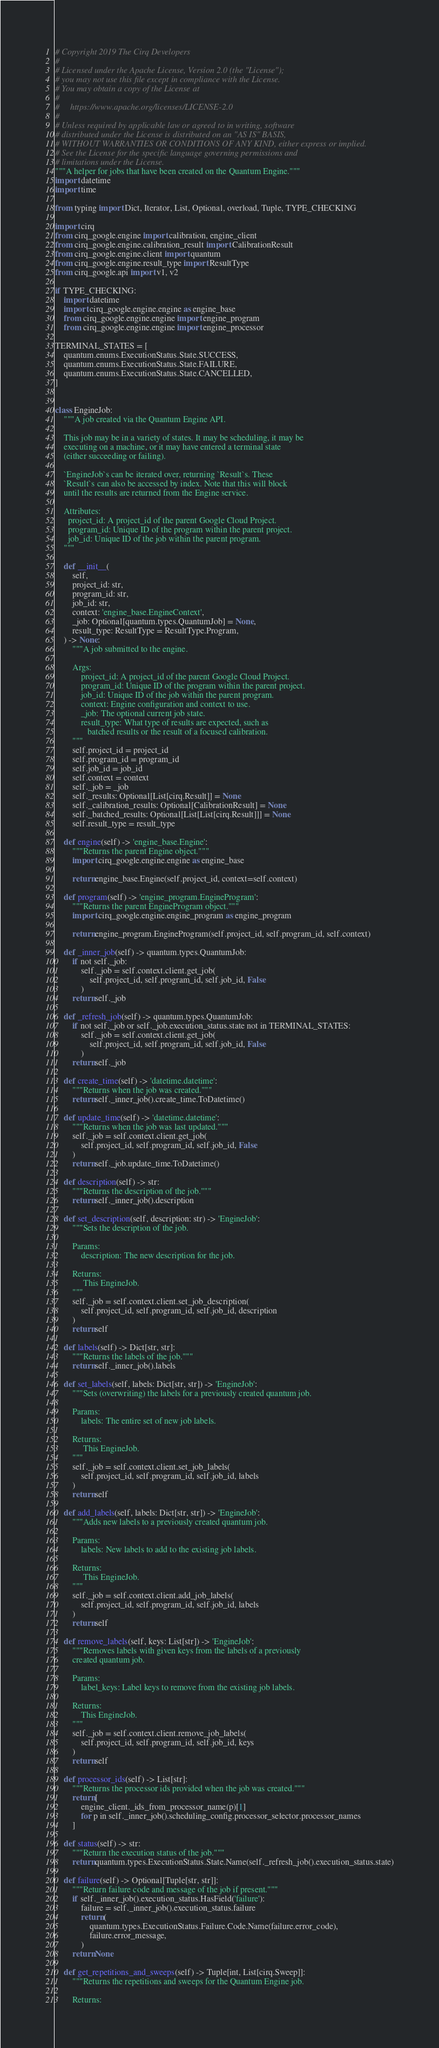<code> <loc_0><loc_0><loc_500><loc_500><_Python_># Copyright 2019 The Cirq Developers
#
# Licensed under the Apache License, Version 2.0 (the "License");
# you may not use this file except in compliance with the License.
# You may obtain a copy of the License at
#
#     https://www.apache.org/licenses/LICENSE-2.0
#
# Unless required by applicable law or agreed to in writing, software
# distributed under the License is distributed on an "AS IS" BASIS,
# WITHOUT WARRANTIES OR CONDITIONS OF ANY KIND, either express or implied.
# See the License for the specific language governing permissions and
# limitations under the License.
"""A helper for jobs that have been created on the Quantum Engine."""
import datetime
import time

from typing import Dict, Iterator, List, Optional, overload, Tuple, TYPE_CHECKING

import cirq
from cirq_google.engine import calibration, engine_client
from cirq_google.engine.calibration_result import CalibrationResult
from cirq_google.engine.client import quantum
from cirq_google.engine.result_type import ResultType
from cirq_google.api import v1, v2

if TYPE_CHECKING:
    import datetime
    import cirq_google.engine.engine as engine_base
    from cirq_google.engine.engine import engine_program
    from cirq_google.engine.engine import engine_processor

TERMINAL_STATES = [
    quantum.enums.ExecutionStatus.State.SUCCESS,
    quantum.enums.ExecutionStatus.State.FAILURE,
    quantum.enums.ExecutionStatus.State.CANCELLED,
]


class EngineJob:
    """A job created via the Quantum Engine API.

    This job may be in a variety of states. It may be scheduling, it may be
    executing on a machine, or it may have entered a terminal state
    (either succeeding or failing).

    `EngineJob`s can be iterated over, returning `Result`s. These
    `Result`s can also be accessed by index. Note that this will block
    until the results are returned from the Engine service.

    Attributes:
      project_id: A project_id of the parent Google Cloud Project.
      program_id: Unique ID of the program within the parent project.
      job_id: Unique ID of the job within the parent program.
    """

    def __init__(
        self,
        project_id: str,
        program_id: str,
        job_id: str,
        context: 'engine_base.EngineContext',
        _job: Optional[quantum.types.QuantumJob] = None,
        result_type: ResultType = ResultType.Program,
    ) -> None:
        """A job submitted to the engine.

        Args:
            project_id: A project_id of the parent Google Cloud Project.
            program_id: Unique ID of the program within the parent project.
            job_id: Unique ID of the job within the parent program.
            context: Engine configuration and context to use.
            _job: The optional current job state.
            result_type: What type of results are expected, such as
               batched results or the result of a focused calibration.
        """
        self.project_id = project_id
        self.program_id = program_id
        self.job_id = job_id
        self.context = context
        self._job = _job
        self._results: Optional[List[cirq.Result]] = None
        self._calibration_results: Optional[CalibrationResult] = None
        self._batched_results: Optional[List[List[cirq.Result]]] = None
        self.result_type = result_type

    def engine(self) -> 'engine_base.Engine':
        """Returns the parent Engine object."""
        import cirq_google.engine.engine as engine_base

        return engine_base.Engine(self.project_id, context=self.context)

    def program(self) -> 'engine_program.EngineProgram':
        """Returns the parent EngineProgram object."""
        import cirq_google.engine.engine_program as engine_program

        return engine_program.EngineProgram(self.project_id, self.program_id, self.context)

    def _inner_job(self) -> quantum.types.QuantumJob:
        if not self._job:
            self._job = self.context.client.get_job(
                self.project_id, self.program_id, self.job_id, False
            )
        return self._job

    def _refresh_job(self) -> quantum.types.QuantumJob:
        if not self._job or self._job.execution_status.state not in TERMINAL_STATES:
            self._job = self.context.client.get_job(
                self.project_id, self.program_id, self.job_id, False
            )
        return self._job

    def create_time(self) -> 'datetime.datetime':
        """Returns when the job was created."""
        return self._inner_job().create_time.ToDatetime()

    def update_time(self) -> 'datetime.datetime':
        """Returns when the job was last updated."""
        self._job = self.context.client.get_job(
            self.project_id, self.program_id, self.job_id, False
        )
        return self._job.update_time.ToDatetime()

    def description(self) -> str:
        """Returns the description of the job."""
        return self._inner_job().description

    def set_description(self, description: str) -> 'EngineJob':
        """Sets the description of the job.

        Params:
            description: The new description for the job.

        Returns:
             This EngineJob.
        """
        self._job = self.context.client.set_job_description(
            self.project_id, self.program_id, self.job_id, description
        )
        return self

    def labels(self) -> Dict[str, str]:
        """Returns the labels of the job."""
        return self._inner_job().labels

    def set_labels(self, labels: Dict[str, str]) -> 'EngineJob':
        """Sets (overwriting) the labels for a previously created quantum job.

        Params:
            labels: The entire set of new job labels.

        Returns:
             This EngineJob.
        """
        self._job = self.context.client.set_job_labels(
            self.project_id, self.program_id, self.job_id, labels
        )
        return self

    def add_labels(self, labels: Dict[str, str]) -> 'EngineJob':
        """Adds new labels to a previously created quantum job.

        Params:
            labels: New labels to add to the existing job labels.

        Returns:
             This EngineJob.
        """
        self._job = self.context.client.add_job_labels(
            self.project_id, self.program_id, self.job_id, labels
        )
        return self

    def remove_labels(self, keys: List[str]) -> 'EngineJob':
        """Removes labels with given keys from the labels of a previously
        created quantum job.

        Params:
            label_keys: Label keys to remove from the existing job labels.

        Returns:
            This EngineJob.
        """
        self._job = self.context.client.remove_job_labels(
            self.project_id, self.program_id, self.job_id, keys
        )
        return self

    def processor_ids(self) -> List[str]:
        """Returns the processor ids provided when the job was created."""
        return [
            engine_client._ids_from_processor_name(p)[1]
            for p in self._inner_job().scheduling_config.processor_selector.processor_names
        ]

    def status(self) -> str:
        """Return the execution status of the job."""
        return quantum.types.ExecutionStatus.State.Name(self._refresh_job().execution_status.state)

    def failure(self) -> Optional[Tuple[str, str]]:
        """Return failure code and message of the job if present."""
        if self._inner_job().execution_status.HasField('failure'):
            failure = self._inner_job().execution_status.failure
            return (
                quantum.types.ExecutionStatus.Failure.Code.Name(failure.error_code),
                failure.error_message,
            )
        return None

    def get_repetitions_and_sweeps(self) -> Tuple[int, List[cirq.Sweep]]:
        """Returns the repetitions and sweeps for the Quantum Engine job.

        Returns:</code> 